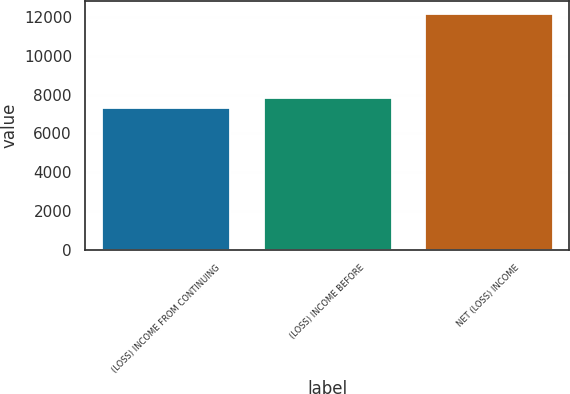Convert chart. <chart><loc_0><loc_0><loc_500><loc_500><bar_chart><fcel>(LOSS) INCOME FROM CONTINUING<fcel>(LOSS) INCOME BEFORE<fcel>NET (LOSS) INCOME<nl><fcel>7370<fcel>7855.5<fcel>12225<nl></chart> 